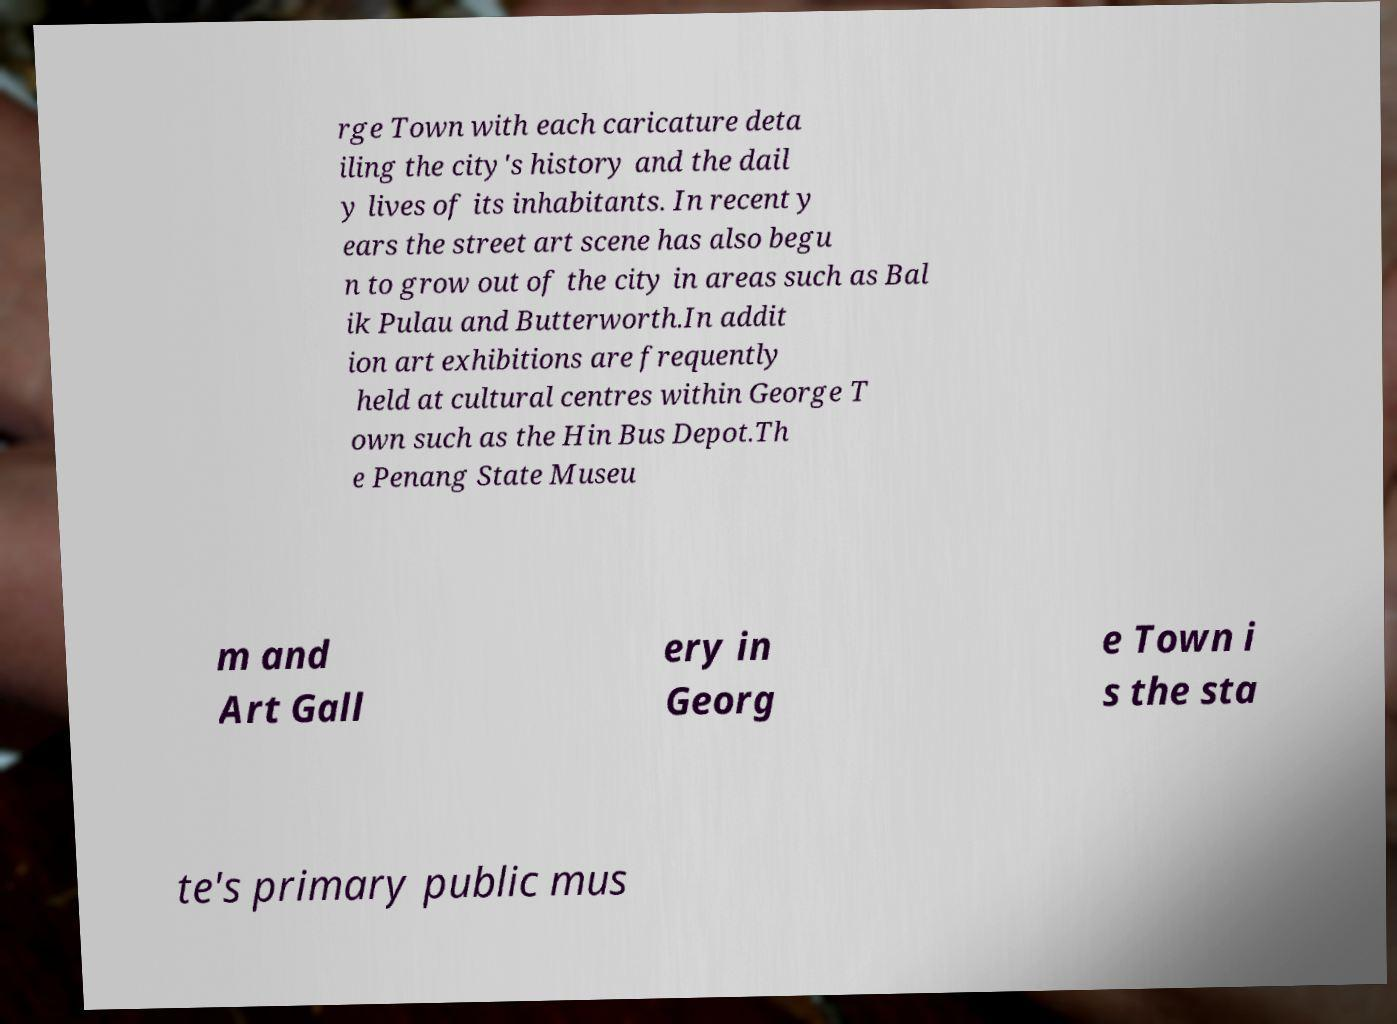Could you extract and type out the text from this image? rge Town with each caricature deta iling the city's history and the dail y lives of its inhabitants. In recent y ears the street art scene has also begu n to grow out of the city in areas such as Bal ik Pulau and Butterworth.In addit ion art exhibitions are frequently held at cultural centres within George T own such as the Hin Bus Depot.Th e Penang State Museu m and Art Gall ery in Georg e Town i s the sta te's primary public mus 